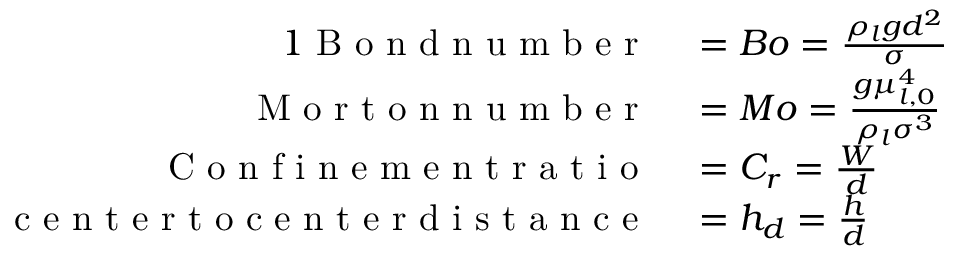Convert formula to latex. <formula><loc_0><loc_0><loc_500><loc_500>\begin{array} { r l } { { 1 } B o n d n u m b e r } & = B o = \frac { \rho _ { l } g d ^ { 2 } } { \sigma } } \\ { M o r t o n n u m b e r } & = M o = \frac { g \mu _ { l , 0 } ^ { 4 } } { \rho _ { l } \sigma ^ { 3 } } } \\ { C o n f i n e m e n t r a t i o } & = C _ { r } = \frac { W } { d } } \\ { c e n t e r t o c e n t e r d i s t a n c e } & = h _ { d } = \frac { h } { d } } \end{array}</formula> 